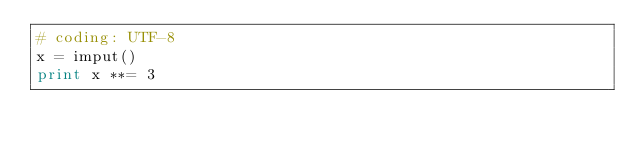Convert code to text. <code><loc_0><loc_0><loc_500><loc_500><_Python_># coding: UTF-8
x = imput()
print x **= 3
</code> 